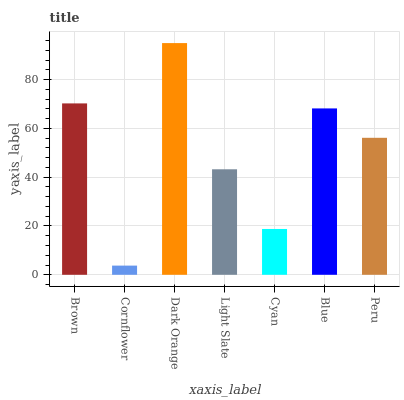Is Cornflower the minimum?
Answer yes or no. Yes. Is Dark Orange the maximum?
Answer yes or no. Yes. Is Dark Orange the minimum?
Answer yes or no. No. Is Cornflower the maximum?
Answer yes or no. No. Is Dark Orange greater than Cornflower?
Answer yes or no. Yes. Is Cornflower less than Dark Orange?
Answer yes or no. Yes. Is Cornflower greater than Dark Orange?
Answer yes or no. No. Is Dark Orange less than Cornflower?
Answer yes or no. No. Is Peru the high median?
Answer yes or no. Yes. Is Peru the low median?
Answer yes or no. Yes. Is Brown the high median?
Answer yes or no. No. Is Light Slate the low median?
Answer yes or no. No. 